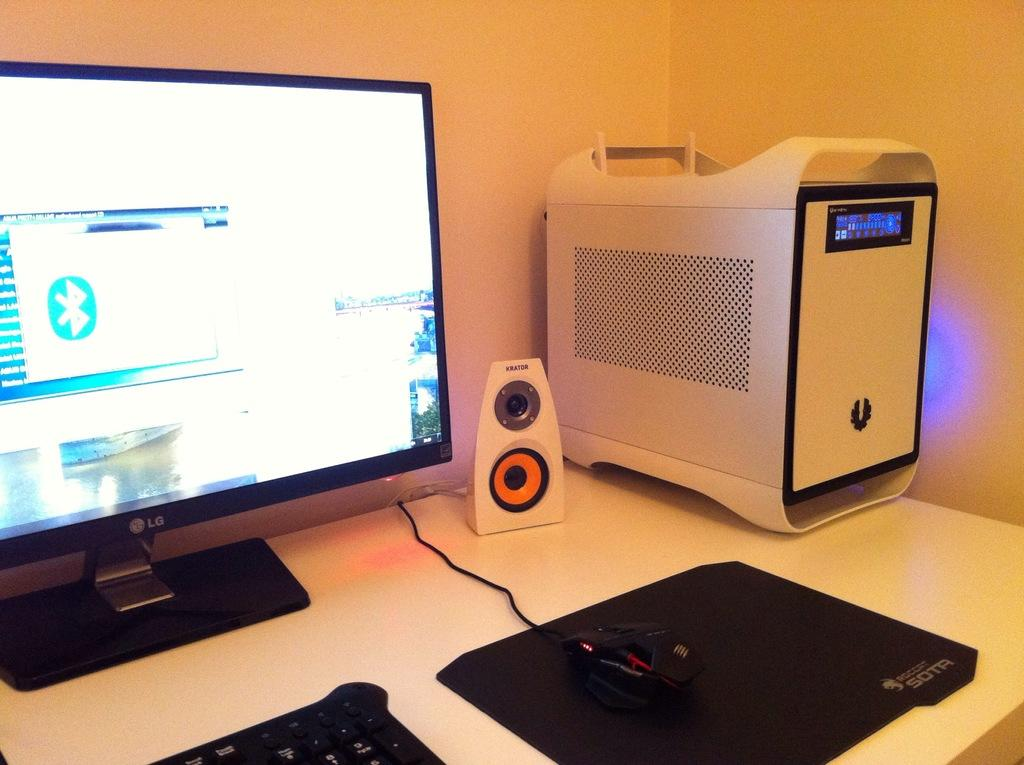Provide a one-sentence caption for the provided image. An LG monitor and Krator speakers next to a tower computer ona desk. 